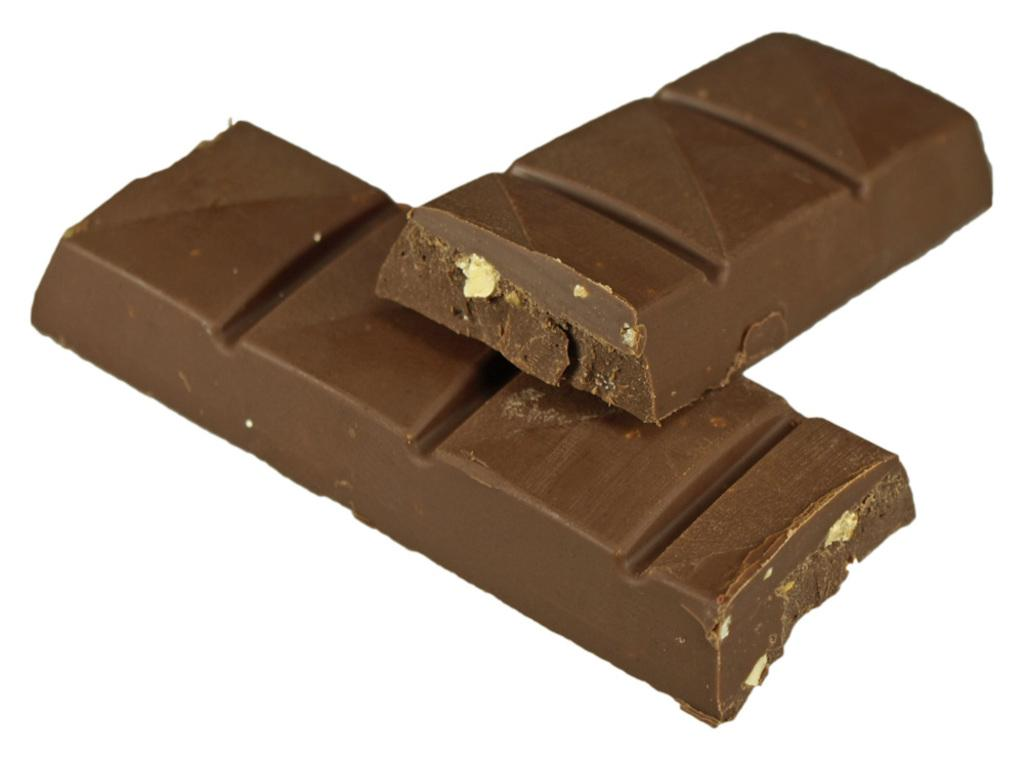What type of food is present in the image? There are chocolate bars in the image. What type of juice can be seen being consumed by the crowd in the image? There is no juice or crowd present in the image; it only features chocolate bars. 